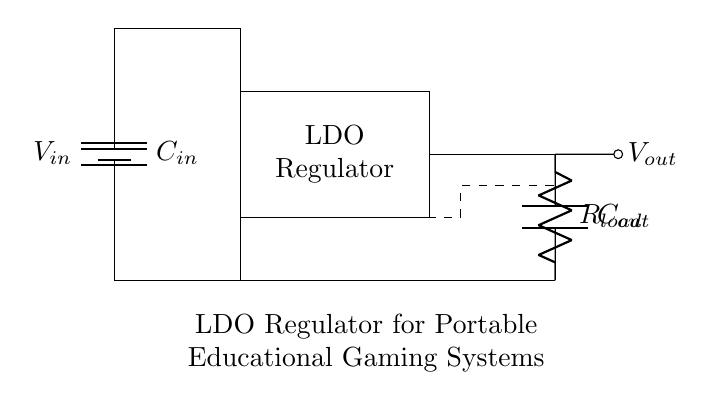What is the input voltage to the LDO? The input voltage, denoted as V in, is represented by the battery symbol on the left side of the circuit.
Answer: V in What is the function of the capacitor C in? Capacitor C in is used for stabilizing the input voltage and filtering any noise before it reaches the LDO regulator.
Answer: Filtering What is the purpose of the feedback in the circuit? The feedback, represented by the dashed lines, is used to regulate the output voltage by returning a portion of it to the regulator for comparison with the reference voltage.
Answer: Regulation What is the load represented in the circuit? The load is represented by the resistor labeled R load, connected to the output of the LDO, indicating the component that draws current from the regulated output voltage.
Answer: R load What type of regulator is illustrated in the circuit? The circuit illustrates a low dropout regulator, which maintains output voltage with minimal difference between input and output voltages.
Answer: Low dropout regulator What is the output voltage of the LDO in relation to the input? The output voltage, denoted as V out, is typically less than the input voltage V in, as LDOs convert higher voltages to lower, regulated levels for proper operation in devices.
Answer: V out < V in 